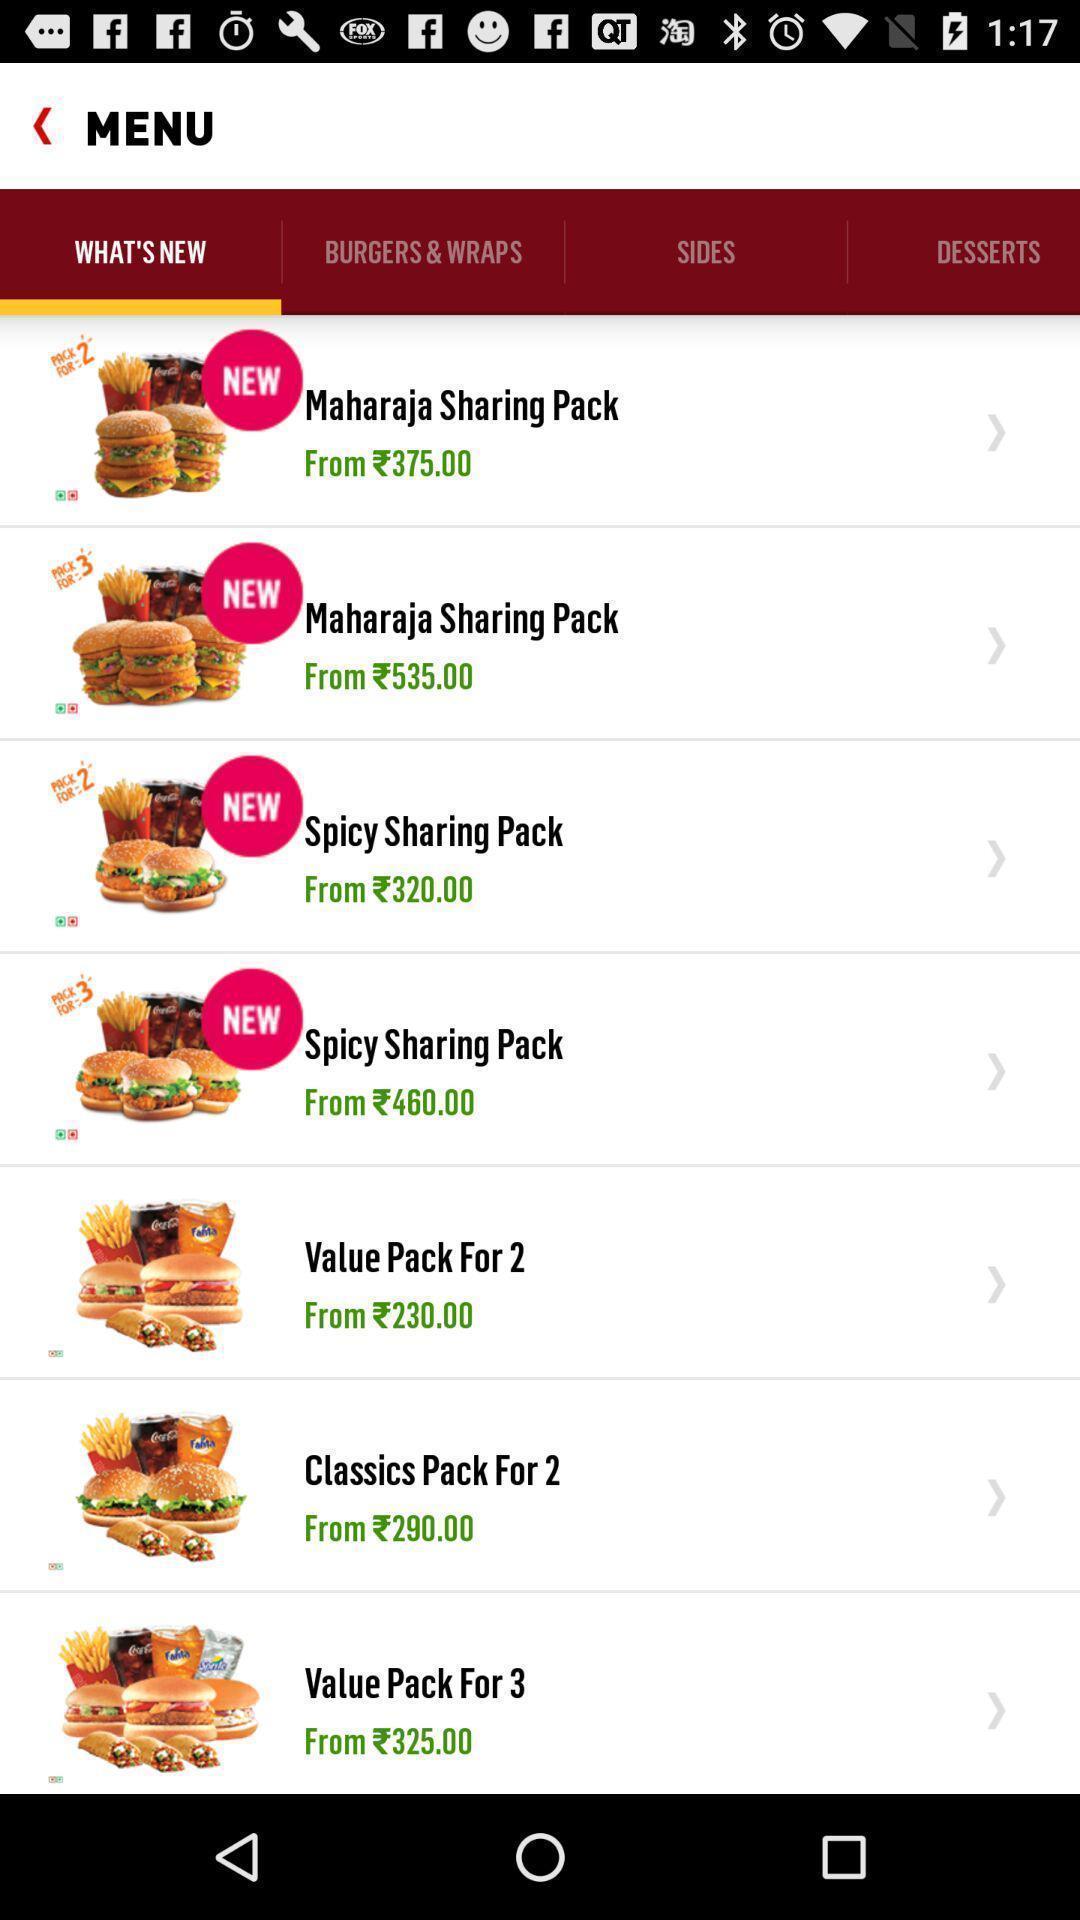Tell me what you see in this picture. Screen page displaying various food items in food application. 